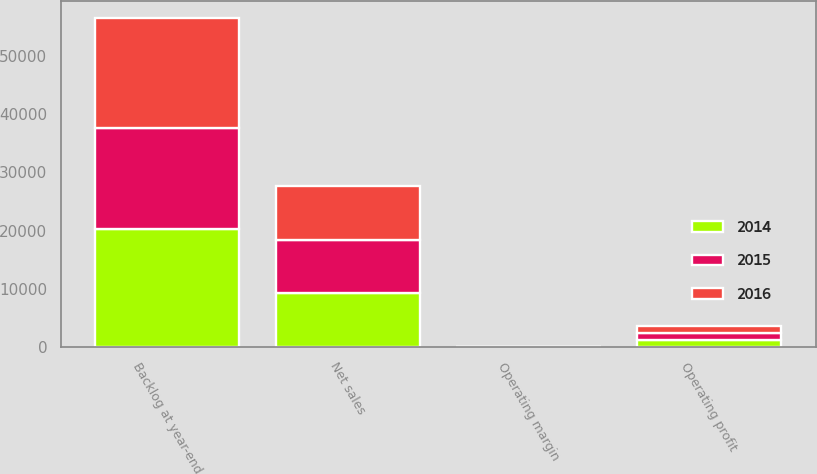<chart> <loc_0><loc_0><loc_500><loc_500><stacked_bar_chart><ecel><fcel>Net sales<fcel>Operating profit<fcel>Operating margin<fcel>Backlog at year-end<nl><fcel>2016<fcel>9409<fcel>1289<fcel>13.7<fcel>18900<nl><fcel>2015<fcel>9105<fcel>1171<fcel>12.9<fcel>17400<nl><fcel>2014<fcel>9202<fcel>1187<fcel>12.9<fcel>20300<nl></chart> 